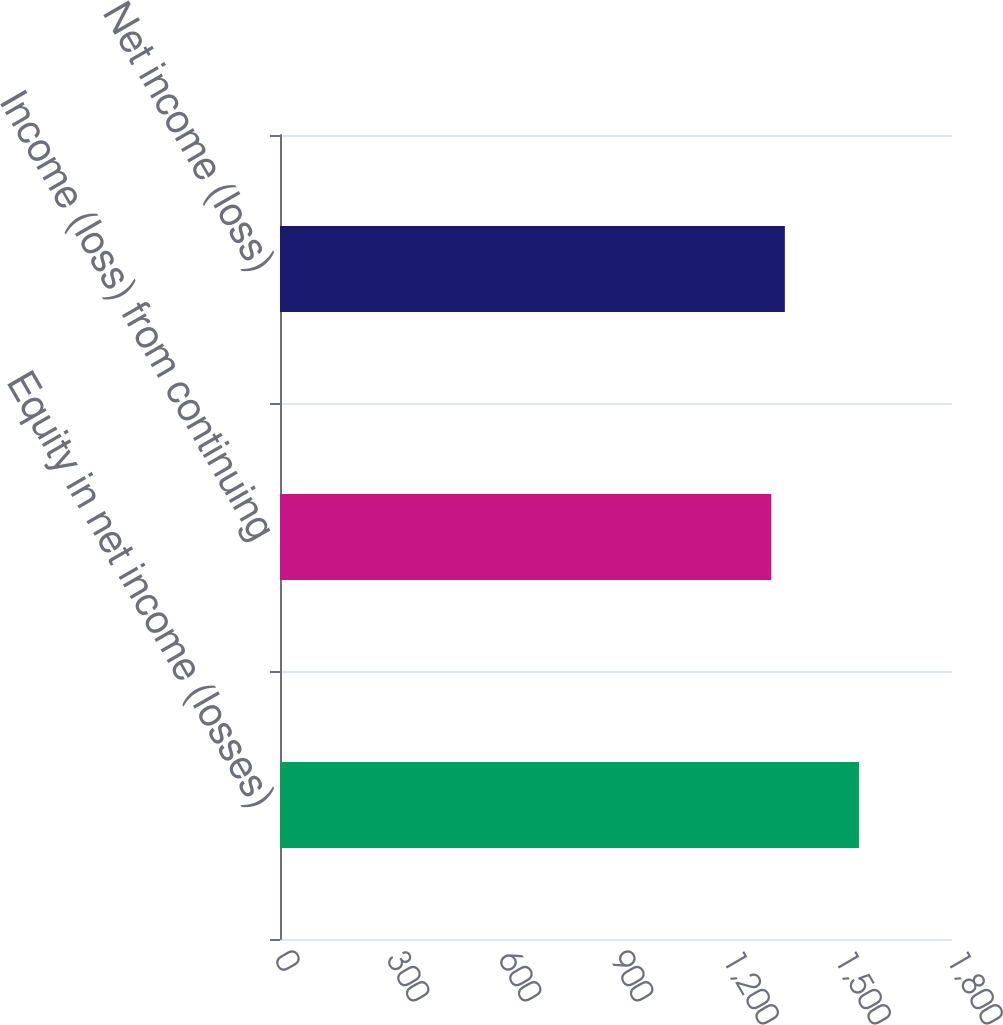Convert chart to OTSL. <chart><loc_0><loc_0><loc_500><loc_500><bar_chart><fcel>Equity in net income (losses)<fcel>Income (loss) from continuing<fcel>Net income (loss)<nl><fcel>1551<fcel>1316<fcel>1352.3<nl></chart> 